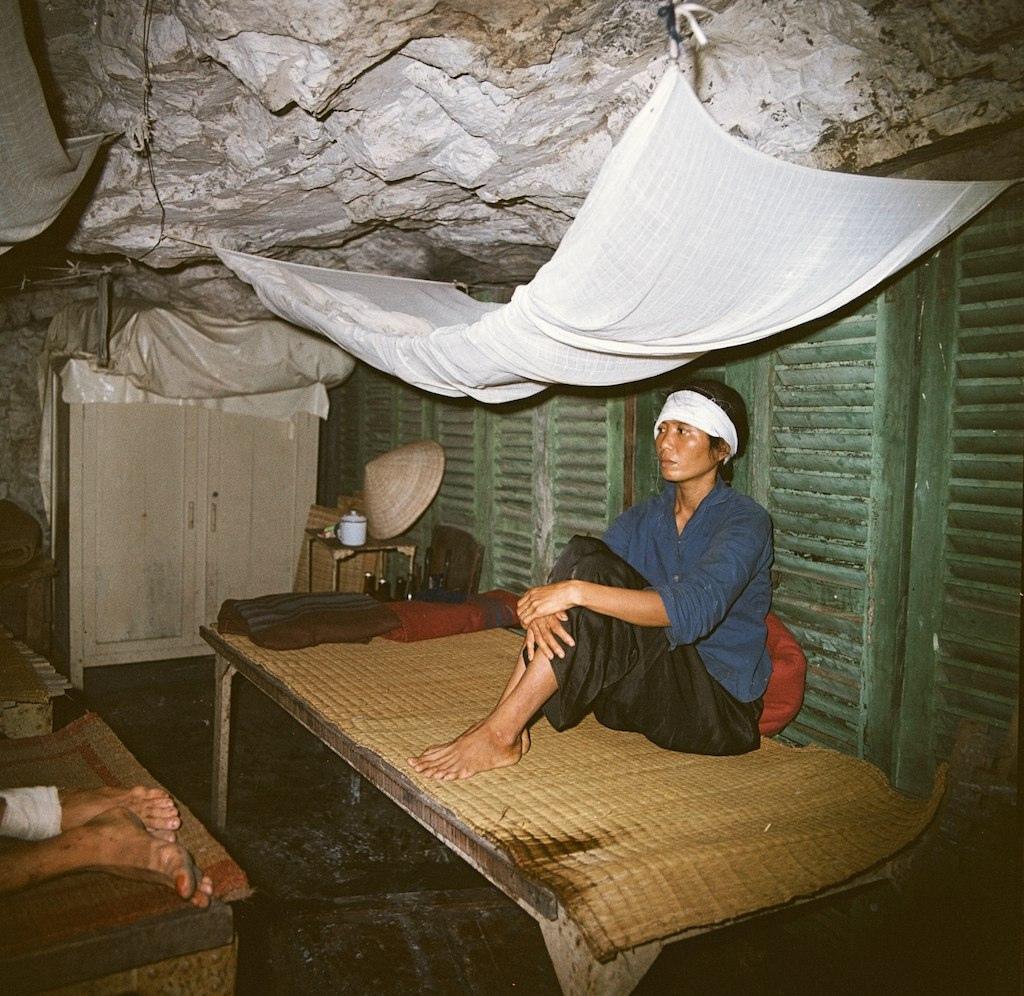Could you give a brief overview of what you see in this image? In this image we can see a man sitting on the cot. In addition to this there are a cupboard, beverage bottles, hat and an another person lying on the cot. 